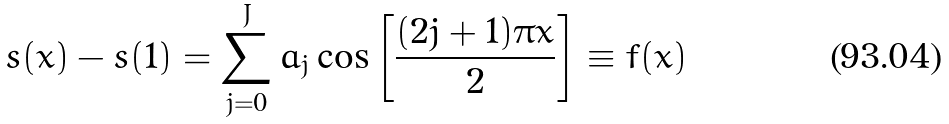<formula> <loc_0><loc_0><loc_500><loc_500>s ( x ) - s ( 1 ) = \sum _ { j = 0 } ^ { J } a _ { j } \cos \left [ \frac { ( 2 j + 1 ) \pi x } { 2 } \right ] \equiv f ( x )</formula> 